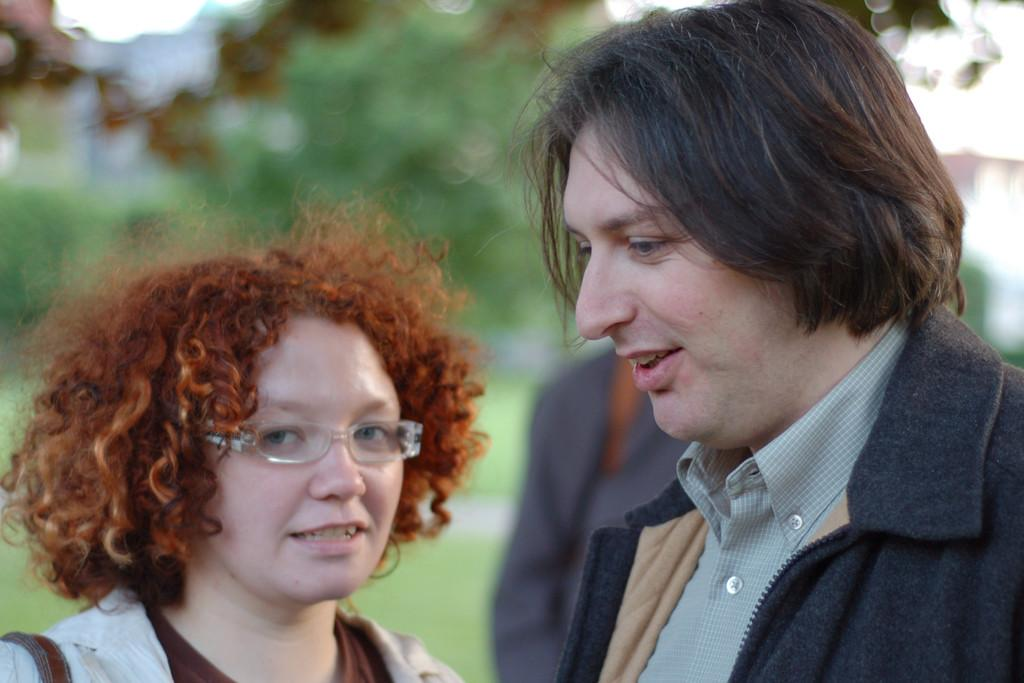How many people are in the image? There are people in the image. What are the people in the image doing? Two people are talking to each other. What type of space is visible in the image? There is no space visible in the image; it features people talking to each other. Can you see an ant in the image? There is no ant present in the image. 